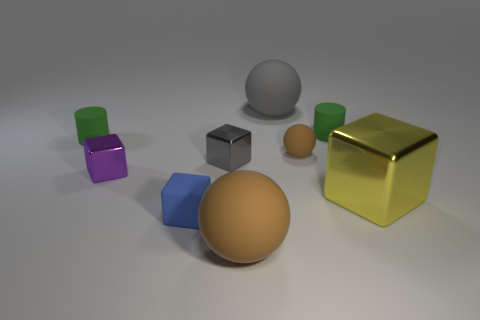What number of other objects are there of the same material as the blue block?
Offer a very short reply. 5. There is a large matte thing that is in front of the cylinder on the left side of the tiny gray block; what is its color?
Keep it short and to the point. Brown. There is a metal cube right of the big brown rubber thing; is it the same color as the small matte cube?
Offer a very short reply. No. Do the gray cube and the gray sphere have the same size?
Ensure brevity in your answer.  No. There is a brown rubber thing that is the same size as the purple metallic block; what shape is it?
Your response must be concise. Sphere. Does the rubber object left of the purple shiny object have the same size as the large cube?
Offer a terse response. No. What material is the purple object that is the same size as the gray block?
Give a very brief answer. Metal. There is a rubber cylinder that is on the right side of the large sphere behind the purple metal cube; is there a large gray object that is in front of it?
Your answer should be compact. No. Is the color of the ball in front of the yellow thing the same as the small rubber thing to the left of the tiny purple object?
Your answer should be very brief. No. Are any large green matte cubes visible?
Your answer should be very brief. No. 